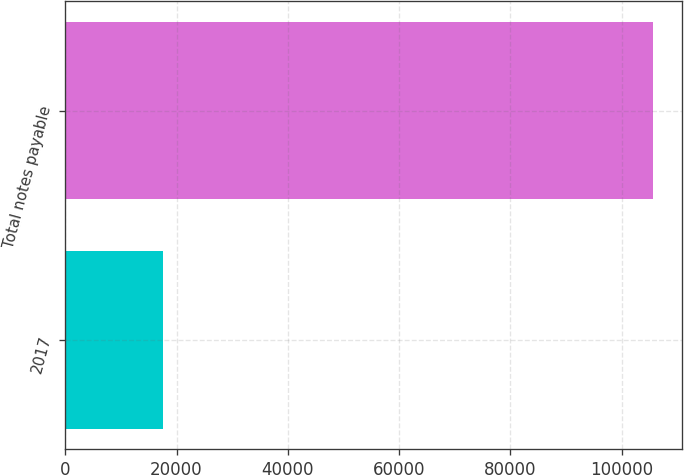Convert chart to OTSL. <chart><loc_0><loc_0><loc_500><loc_500><bar_chart><fcel>2017<fcel>Total notes payable<nl><fcel>17517<fcel>105588<nl></chart> 